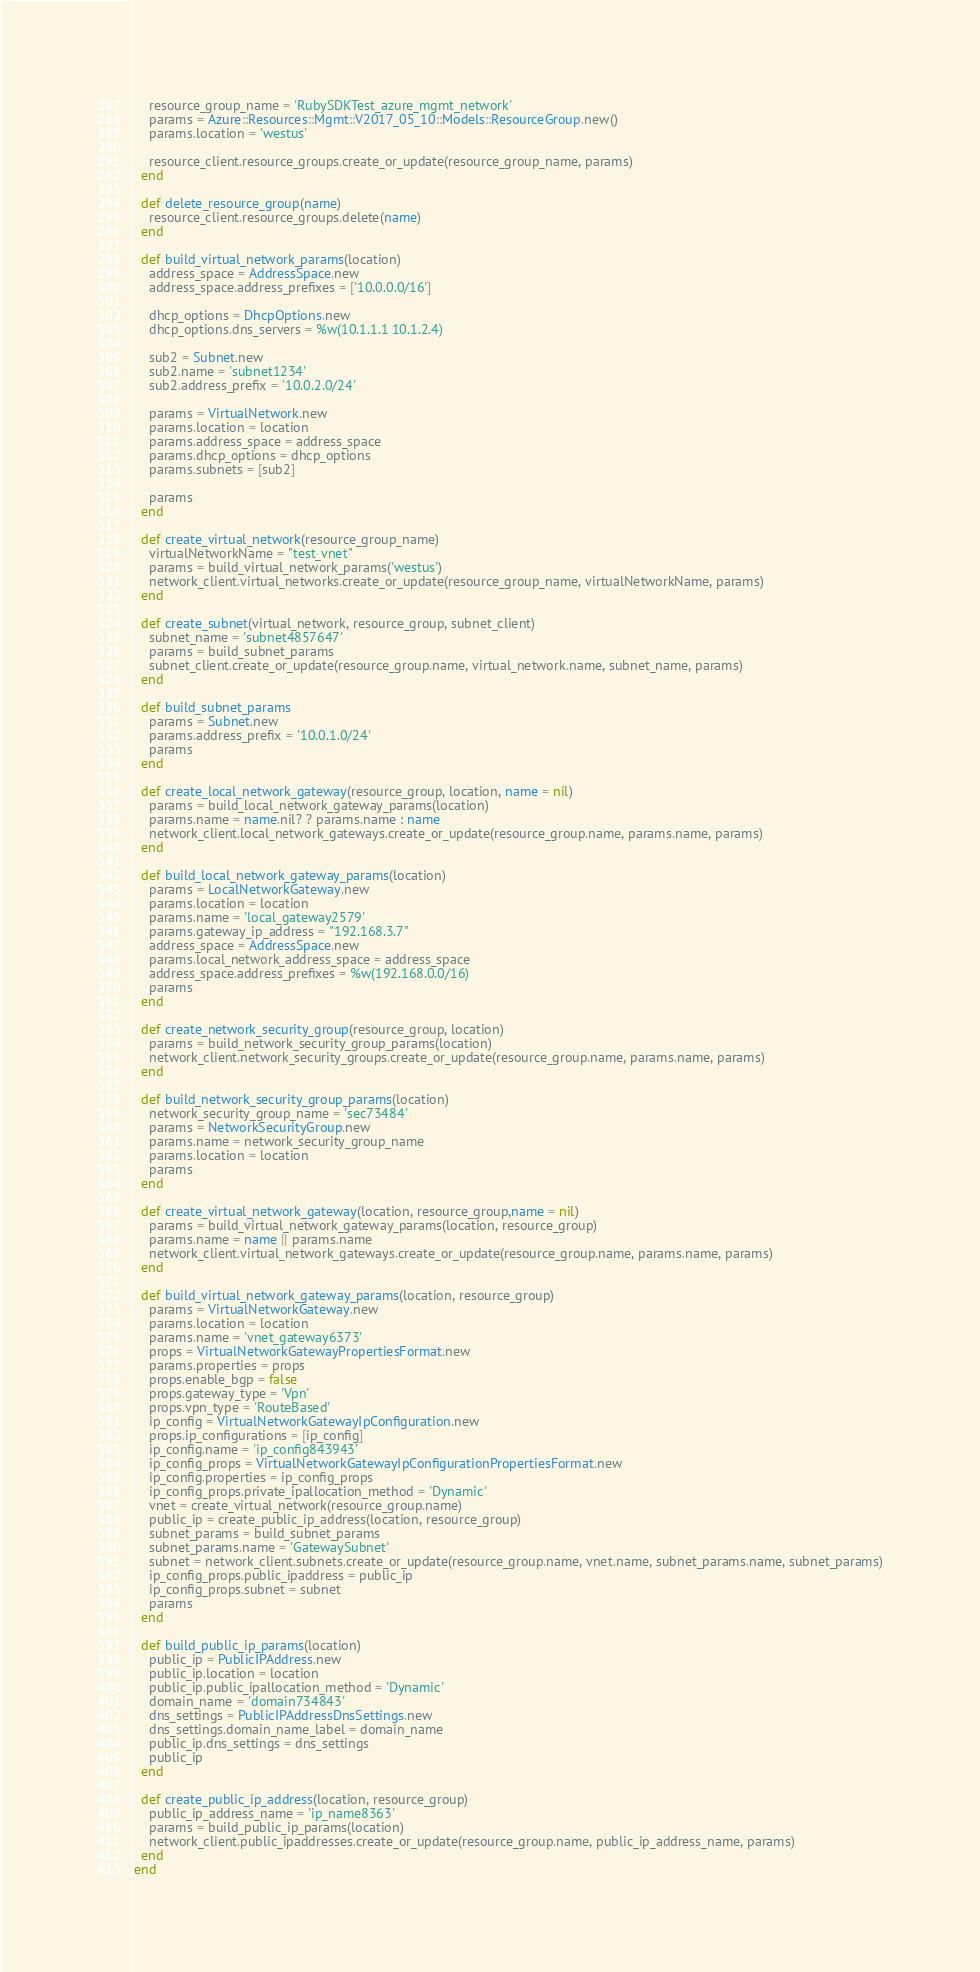<code> <loc_0><loc_0><loc_500><loc_500><_Ruby_>    resource_group_name = 'RubySDKTest_azure_mgmt_network'
    params = Azure::Resources::Mgmt::V2017_05_10::Models::ResourceGroup.new()
    params.location = 'westus'

    resource_client.resource_groups.create_or_update(resource_group_name, params)
  end

  def delete_resource_group(name)
    resource_client.resource_groups.delete(name)
  end

  def build_virtual_network_params(location)
    address_space = AddressSpace.new
    address_space.address_prefixes = ['10.0.0.0/16']

    dhcp_options = DhcpOptions.new
    dhcp_options.dns_servers = %w(10.1.1.1 10.1.2.4)

    sub2 = Subnet.new
    sub2.name = 'subnet1234'
    sub2.address_prefix = '10.0.2.0/24'

    params = VirtualNetwork.new
    params.location = location
    params.address_space = address_space
    params.dhcp_options = dhcp_options
    params.subnets = [sub2]

    params
  end

  def create_virtual_network(resource_group_name)
    virtualNetworkName = "test_vnet"
    params = build_virtual_network_params('westus')
    network_client.virtual_networks.create_or_update(resource_group_name, virtualNetworkName, params)
  end

  def create_subnet(virtual_network, resource_group, subnet_client)
    subnet_name = 'subnet4857647'
    params = build_subnet_params
    subnet_client.create_or_update(resource_group.name, virtual_network.name, subnet_name, params)
  end

  def build_subnet_params
    params = Subnet.new
    params.address_prefix = '10.0.1.0/24'
    params
  end

  def create_local_network_gateway(resource_group, location, name = nil)
    params = build_local_network_gateway_params(location)
    params.name = name.nil? ? params.name : name
    network_client.local_network_gateways.create_or_update(resource_group.name, params.name, params)
  end

  def build_local_network_gateway_params(location)
    params = LocalNetworkGateway.new
    params.location = location
    params.name = 'local_gateway2579'
    params.gateway_ip_address = "192.168.3.7"
    address_space = AddressSpace.new
    params.local_network_address_space = address_space
    address_space.address_prefixes = %w(192.168.0.0/16)
    params
  end

  def create_network_security_group(resource_group, location)
    params = build_network_security_group_params(location)
    network_client.network_security_groups.create_or_update(resource_group.name, params.name, params)
  end

  def build_network_security_group_params(location)
    network_security_group_name = 'sec73484'
    params = NetworkSecurityGroup.new
    params.name = network_security_group_name
    params.location = location
    params
  end

  def create_virtual_network_gateway(location, resource_group,name = nil)
    params = build_virtual_network_gateway_params(location, resource_group)
    params.name = name || params.name
    network_client.virtual_network_gateways.create_or_update(resource_group.name, params.name, params)
  end

  def build_virtual_network_gateway_params(location, resource_group)
    params = VirtualNetworkGateway.new
    params.location = location
    params.name = 'vnet_gateway6373'
    props = VirtualNetworkGatewayPropertiesFormat.new
    params.properties = props
    props.enable_bgp = false
    props.gateway_type = 'Vpn'
    props.vpn_type = 'RouteBased'
    ip_config = VirtualNetworkGatewayIpConfiguration.new
    props.ip_configurations = [ip_config]
    ip_config.name = 'ip_config843943'
    ip_config_props = VirtualNetworkGatewayIpConfigurationPropertiesFormat.new
    ip_config.properties = ip_config_props
    ip_config_props.private_ipallocation_method = 'Dynamic'
    vnet = create_virtual_network(resource_group.name)
    public_ip = create_public_ip_address(location, resource_group)
    subnet_params = build_subnet_params
    subnet_params.name = 'GatewaySubnet'
    subnet = network_client.subnets.create_or_update(resource_group.name, vnet.name, subnet_params.name, subnet_params)
    ip_config_props.public_ipaddress = public_ip
    ip_config_props.subnet = subnet
    params
  end

  def build_public_ip_params(location)
    public_ip = PublicIPAddress.new
    public_ip.location = location
    public_ip.public_ipallocation_method = 'Dynamic'
    domain_name = 'domain734843'
    dns_settings = PublicIPAddressDnsSettings.new
    dns_settings.domain_name_label = domain_name
    public_ip.dns_settings = dns_settings
    public_ip
  end

  def create_public_ip_address(location, resource_group)
    public_ip_address_name = 'ip_name8363'
    params = build_public_ip_params(location)
    network_client.public_ipaddresses.create_or_update(resource_group.name, public_ip_address_name, params)
  end
end
</code> 